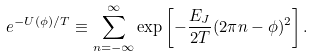<formula> <loc_0><loc_0><loc_500><loc_500>e ^ { - U ( \phi ) / T } \equiv \sum _ { n = - \infty } ^ { \infty } \exp \left [ - \frac { E _ { J } } { 2 T } ( 2 \pi n - \phi ) ^ { 2 } \right ] .</formula> 